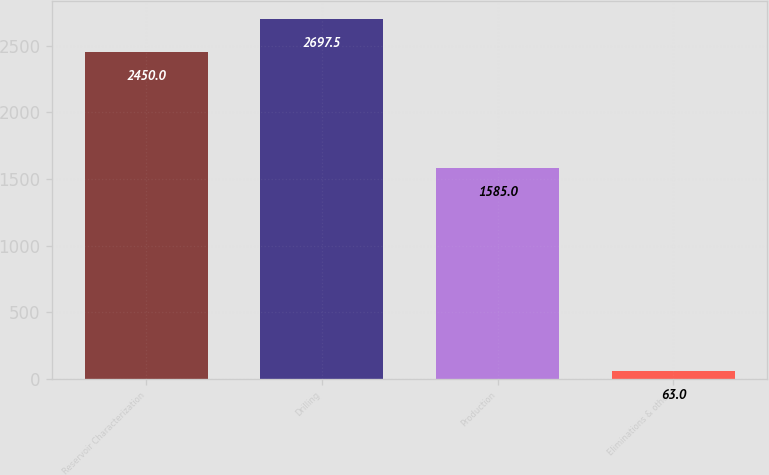<chart> <loc_0><loc_0><loc_500><loc_500><bar_chart><fcel>Reservoir Characterization<fcel>Drilling<fcel>Production<fcel>Eliminations & other<nl><fcel>2450<fcel>2697.5<fcel>1585<fcel>63<nl></chart> 